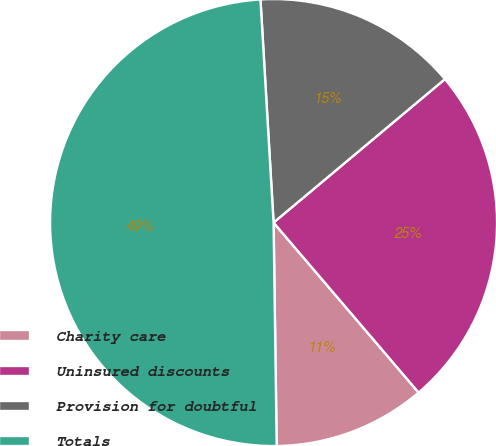<chart> <loc_0><loc_0><loc_500><loc_500><pie_chart><fcel>Charity care<fcel>Uninsured discounts<fcel>Provision for doubtful<fcel>Totals<nl><fcel>11.02%<fcel>24.85%<fcel>14.84%<fcel>49.29%<nl></chart> 